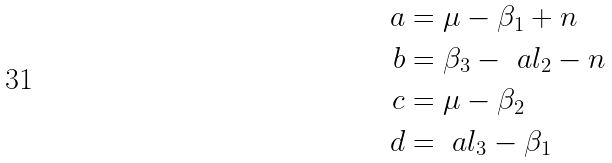Convert formula to latex. <formula><loc_0><loc_0><loc_500><loc_500>a & = \mu - \beta _ { 1 } + n \\ b & = \beta _ { 3 } - \ a l _ { 2 } - n \\ c & = \mu - \beta _ { 2 } \\ d & = \ a l _ { 3 } - \beta _ { 1 }</formula> 